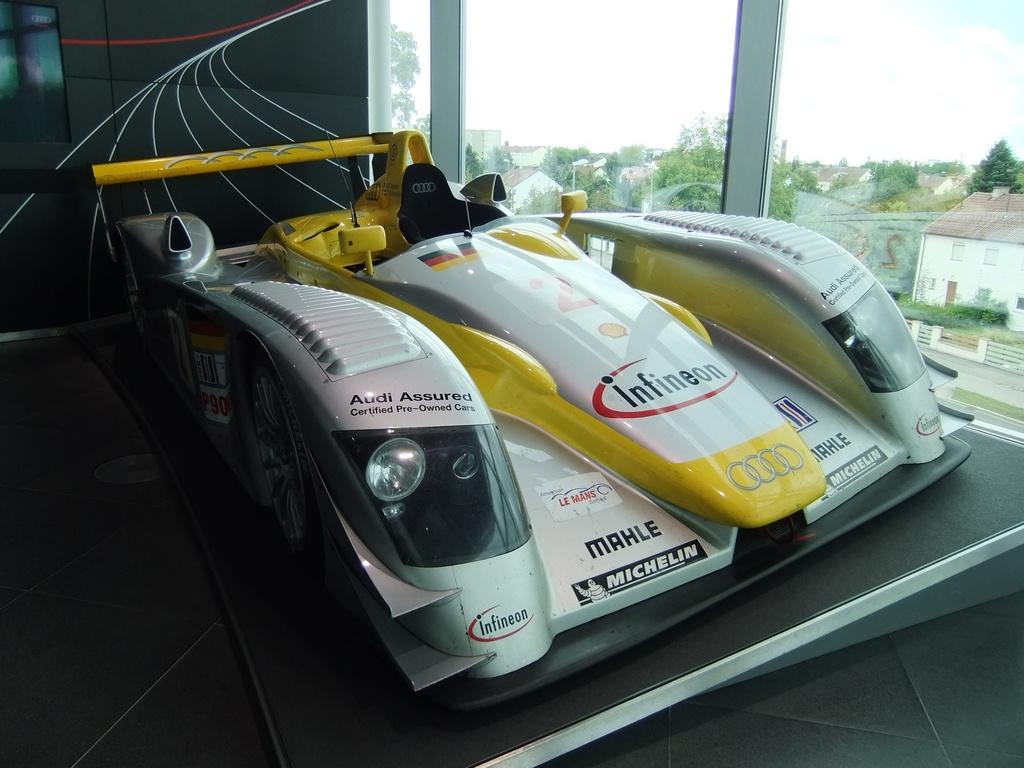What is the main subject of the image? There is a race car in the image. What can be seen in the background of the image? There are trees in the background of the image. What type of structures are visible through the glass door in the background? Houses are visible through the glass door in the background of the image. What type of card is being used to prepare breakfast in the image? There is no card or breakfast preparation visible in the image. 